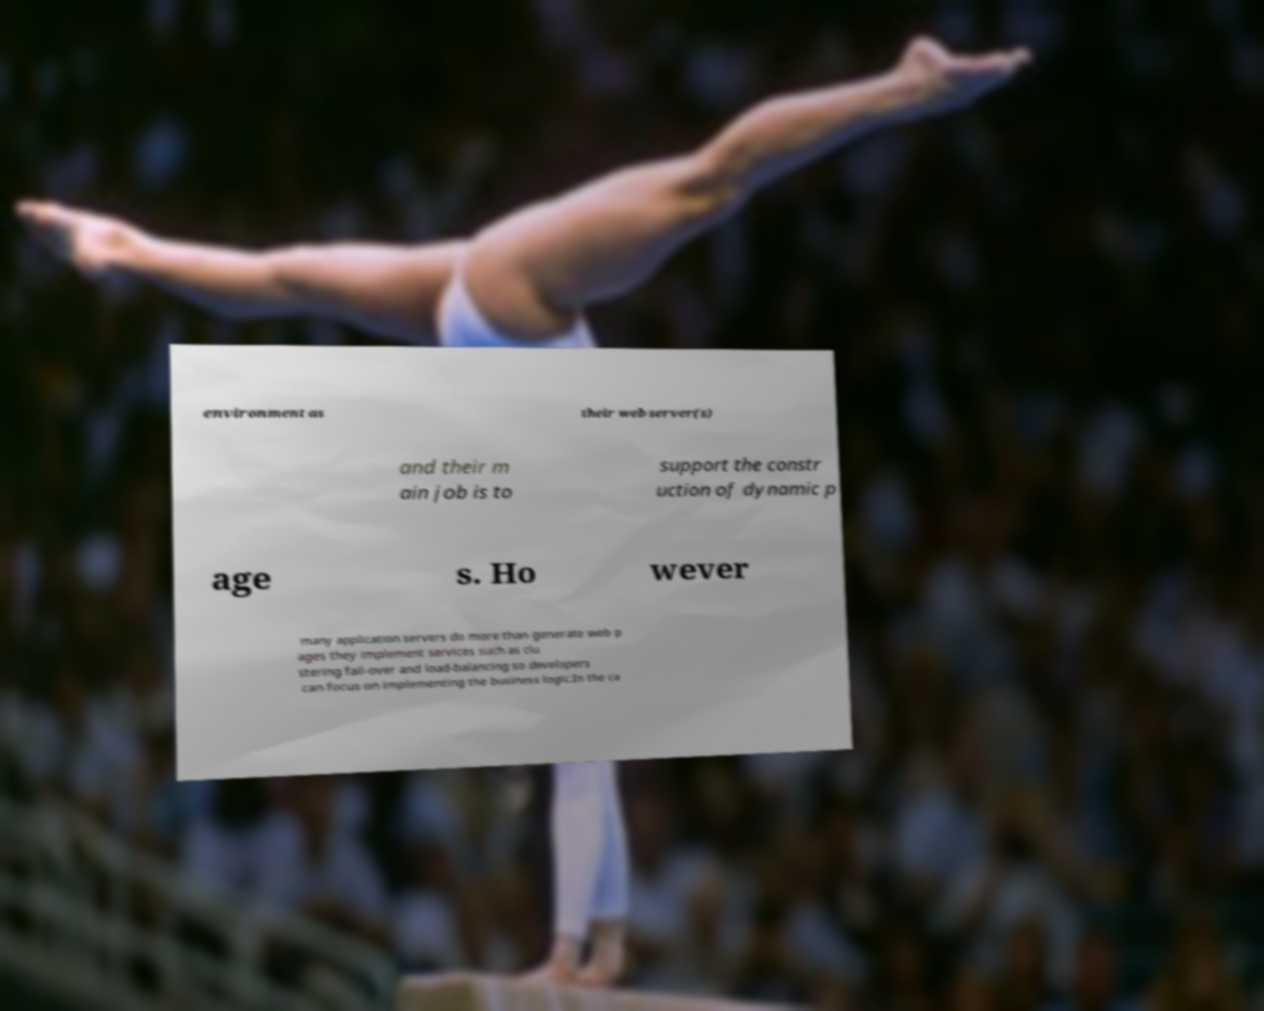Could you extract and type out the text from this image? environment as their web server(s) and their m ain job is to support the constr uction of dynamic p age s. Ho wever many application servers do more than generate web p ages they implement services such as clu stering fail-over and load-balancing so developers can focus on implementing the business logic.In the ca 